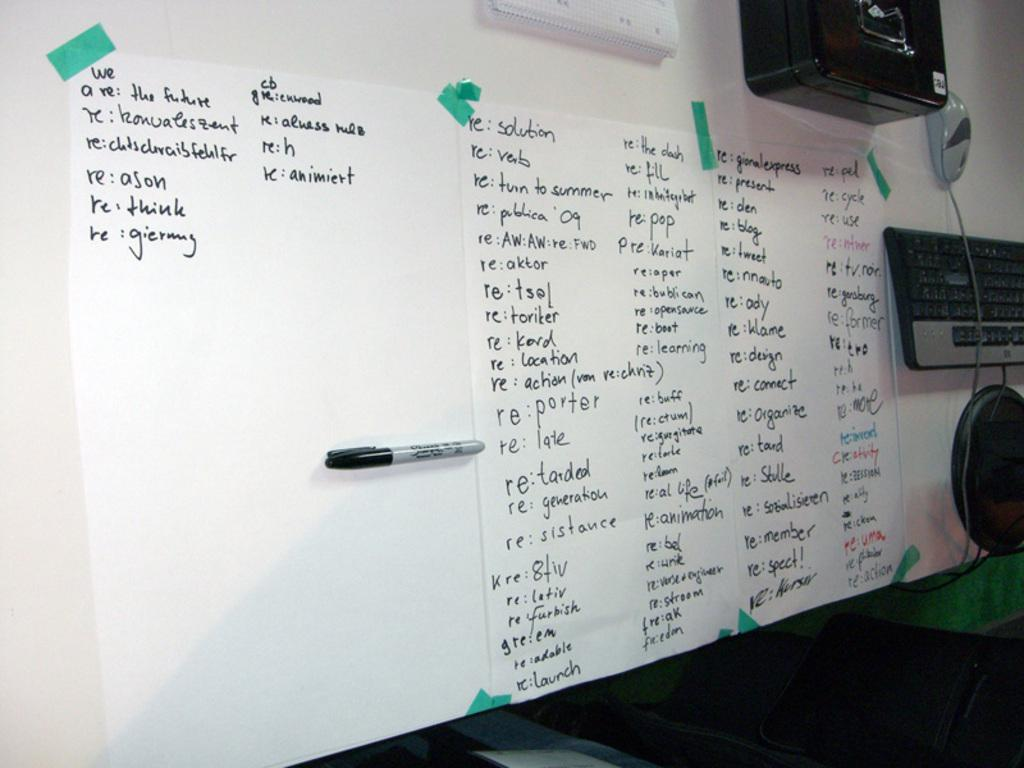<image>
Describe the image concisely. One of the papers taped to the wall has the word solution at the top. 